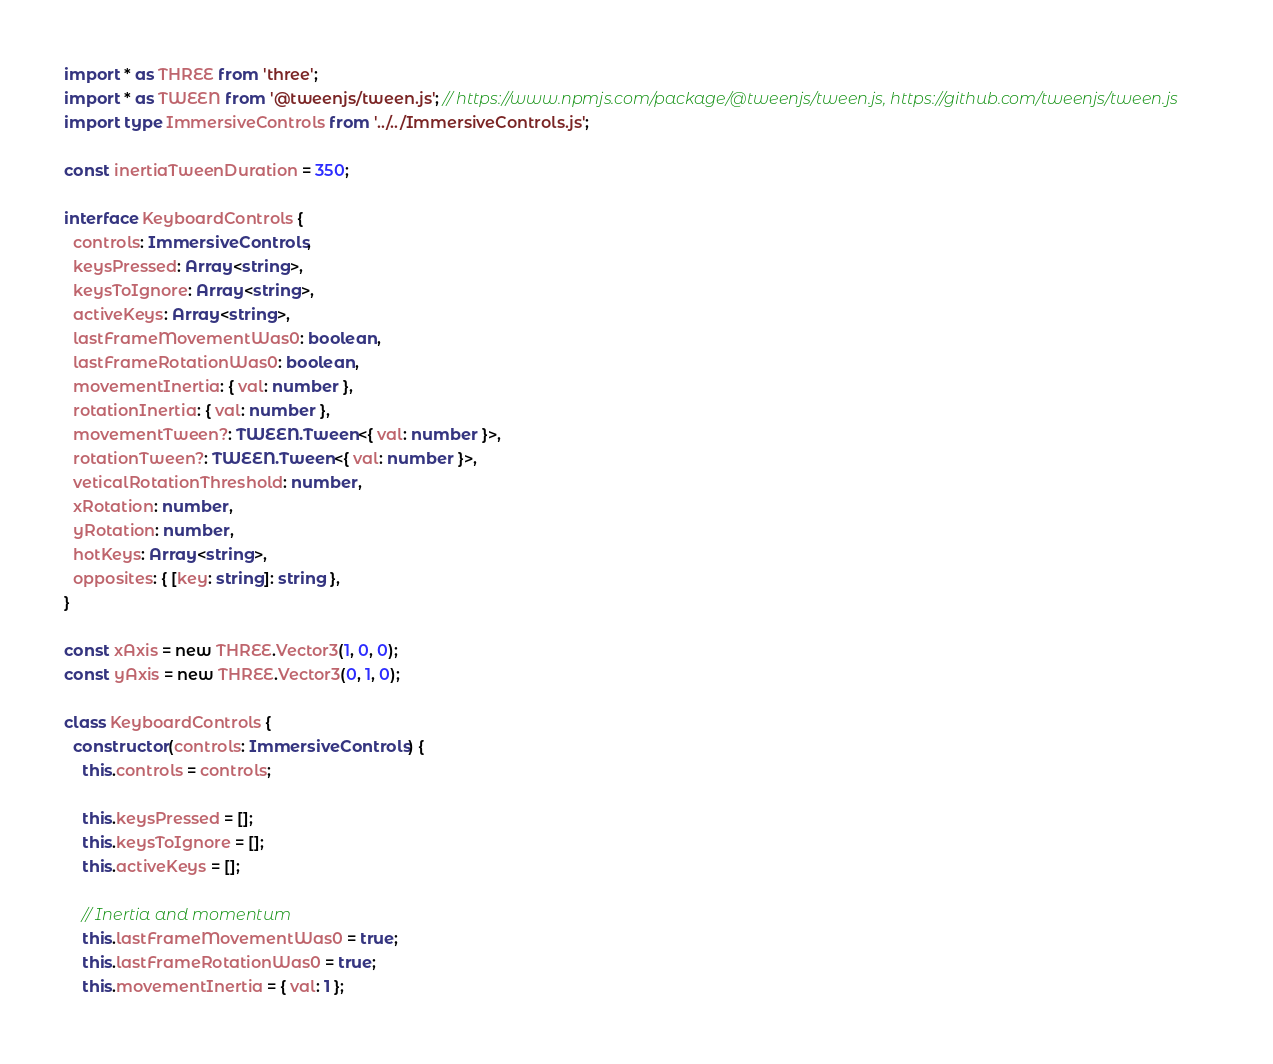Convert code to text. <code><loc_0><loc_0><loc_500><loc_500><_TypeScript_>import * as THREE from 'three';
import * as TWEEN from '@tweenjs/tween.js'; // https://www.npmjs.com/package/@tweenjs/tween.js, https://github.com/tweenjs/tween.js
import type ImmersiveControls from '../../ImmersiveControls.js';

const inertiaTweenDuration = 350;

interface KeyboardControls {
  controls: ImmersiveControls,
  keysPressed: Array<string>,
  keysToIgnore: Array<string>,
  activeKeys: Array<string>,
  lastFrameMovementWas0: boolean,
  lastFrameRotationWas0: boolean,
  movementInertia: { val: number },
  rotationInertia: { val: number },
  movementTween?: TWEEN.Tween<{ val: number }>,
  rotationTween?: TWEEN.Tween<{ val: number }>,
  veticalRotationThreshold: number,
  xRotation: number,
  yRotation: number,
  hotKeys: Array<string>,
  opposites: { [key: string]: string },
}

const xAxis = new THREE.Vector3(1, 0, 0);
const yAxis = new THREE.Vector3(0, 1, 0);

class KeyboardControls {
  constructor(controls: ImmersiveControls) {
    this.controls = controls;

    this.keysPressed = [];
    this.keysToIgnore = [];
    this.activeKeys = [];

    // Inertia and momentum
    this.lastFrameMovementWas0 = true;
    this.lastFrameRotationWas0 = true;
    this.movementInertia = { val: 1 };</code> 